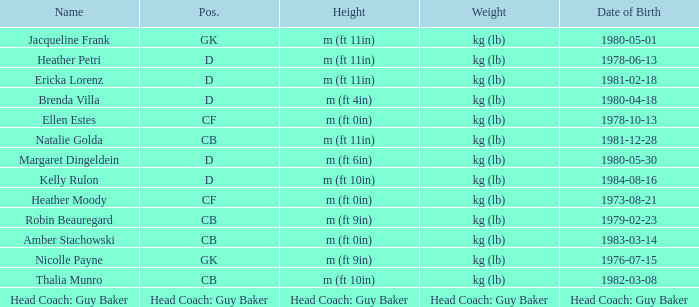Born on 1983-03-14, what is the cb's name? Amber Stachowski. 